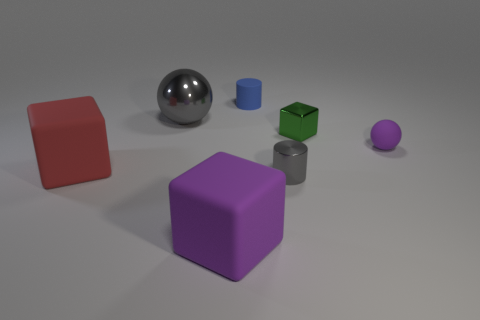Is there a blue thing of the same size as the purple cube?
Offer a terse response. No. What is the size of the ball that is right of the metallic ball?
Make the answer very short. Small. Is there a large gray shiny thing right of the metal ball that is right of the large red matte thing?
Provide a succinct answer. No. How many other things are the same shape as the big purple rubber object?
Your answer should be very brief. 2. Do the large gray metallic thing and the big purple matte object have the same shape?
Provide a short and direct response. No. What is the color of the small thing that is in front of the small green shiny thing and left of the small green object?
Offer a very short reply. Gray. There is a object that is the same color as the metal cylinder; what size is it?
Give a very brief answer. Large. What number of large things are either red things or purple blocks?
Ensure brevity in your answer.  2. Is there any other thing that has the same color as the small metal cube?
Ensure brevity in your answer.  No. The cylinder in front of the sphere on the right side of the small rubber object that is behind the metal ball is made of what material?
Provide a short and direct response. Metal. 